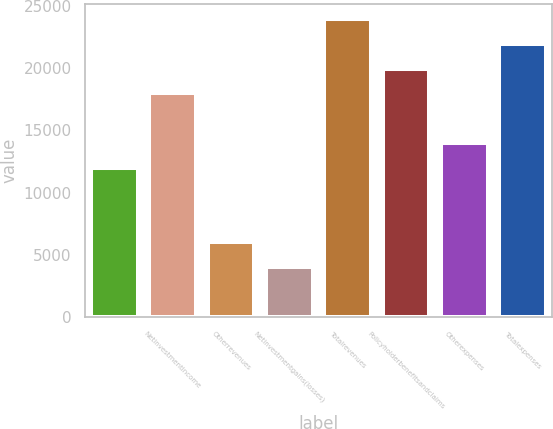Convert chart. <chart><loc_0><loc_0><loc_500><loc_500><bar_chart><ecel><fcel>Netinvestmentincome<fcel>Otherrevenues<fcel>Netinvestmentgains(losses)<fcel>Totalrevenues<fcel>Policyholderbenefitsandclaims<fcel>Otherexpenses<fcel>Totalexpenses<nl><fcel>11992.8<fcel>17965.2<fcel>6020.4<fcel>4029.6<fcel>23937.6<fcel>19956<fcel>13983.6<fcel>21946.8<nl></chart> 